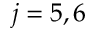Convert formula to latex. <formula><loc_0><loc_0><loc_500><loc_500>j = 5 , 6</formula> 